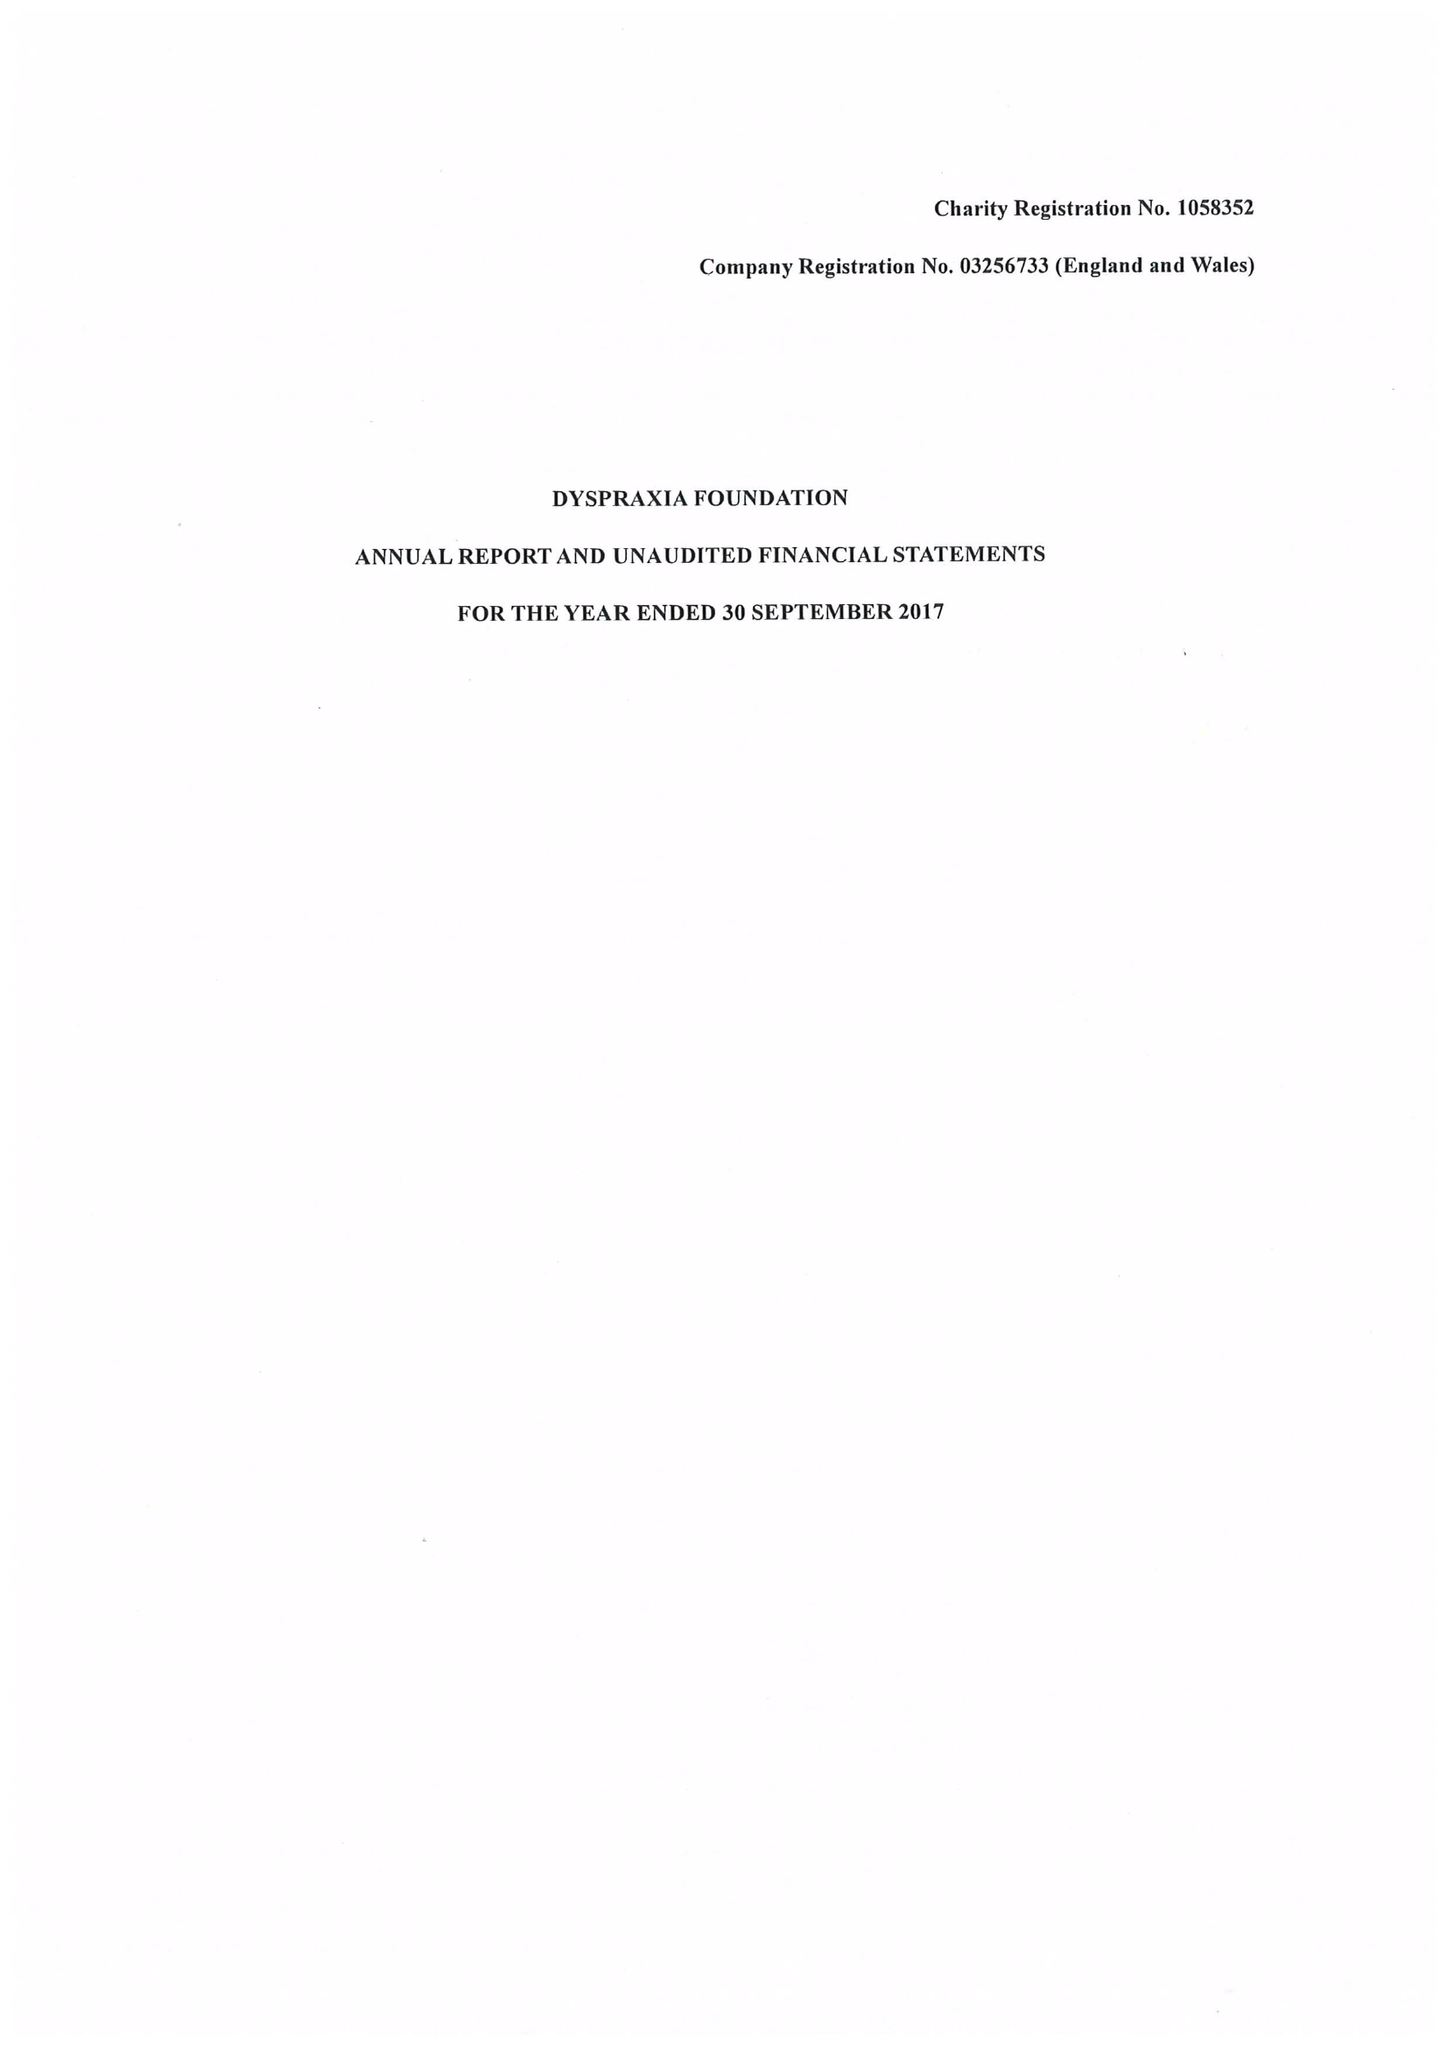What is the value for the charity_number?
Answer the question using a single word or phrase. 1058352 